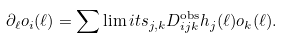<formula> <loc_0><loc_0><loc_500><loc_500>\partial _ { \ell } o _ { i } ( \ell ) = \sum \lim i t s _ { j , k } D _ { i j k } ^ { \text {obs} } h _ { j } ( \ell ) o _ { k } ( \ell ) .</formula> 